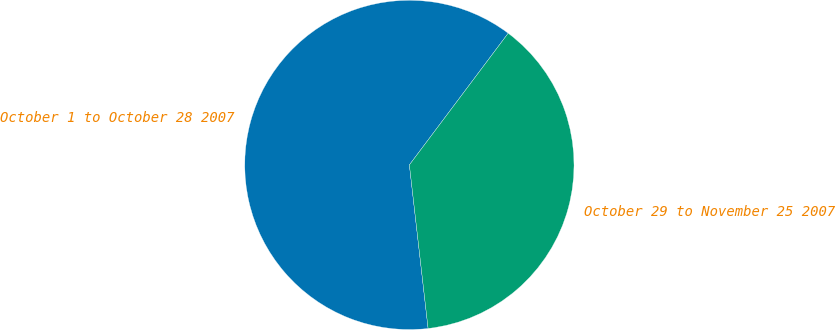<chart> <loc_0><loc_0><loc_500><loc_500><pie_chart><fcel>October 1 to October 28 2007<fcel>October 29 to November 25 2007<nl><fcel>62.06%<fcel>37.94%<nl></chart> 